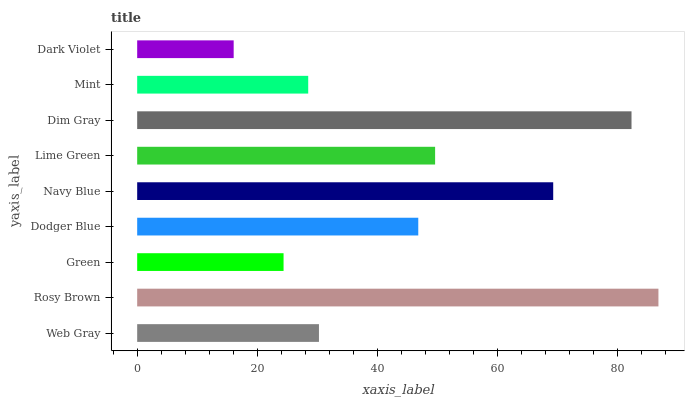Is Dark Violet the minimum?
Answer yes or no. Yes. Is Rosy Brown the maximum?
Answer yes or no. Yes. Is Green the minimum?
Answer yes or no. No. Is Green the maximum?
Answer yes or no. No. Is Rosy Brown greater than Green?
Answer yes or no. Yes. Is Green less than Rosy Brown?
Answer yes or no. Yes. Is Green greater than Rosy Brown?
Answer yes or no. No. Is Rosy Brown less than Green?
Answer yes or no. No. Is Dodger Blue the high median?
Answer yes or no. Yes. Is Dodger Blue the low median?
Answer yes or no. Yes. Is Dim Gray the high median?
Answer yes or no. No. Is Dim Gray the low median?
Answer yes or no. No. 